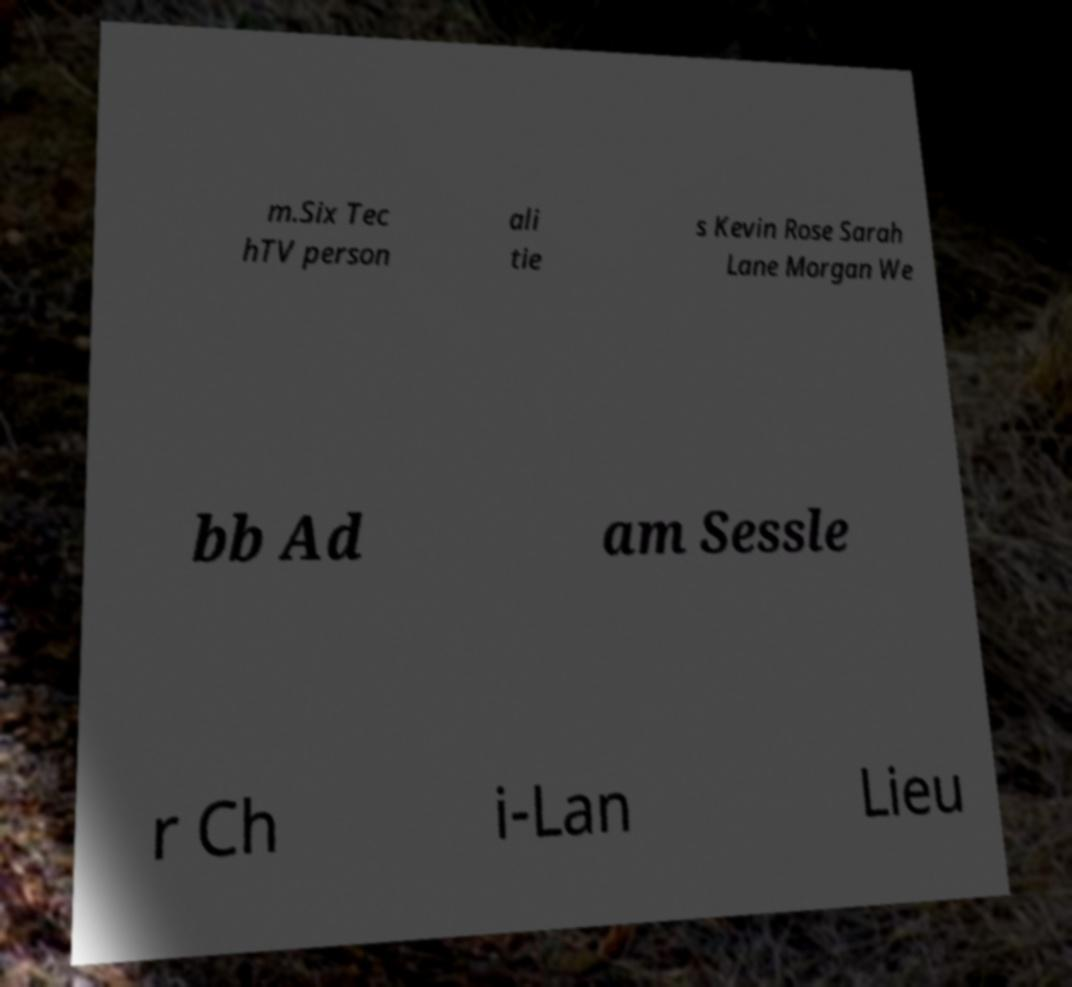What messages or text are displayed in this image? I need them in a readable, typed format. m.Six Tec hTV person ali tie s Kevin Rose Sarah Lane Morgan We bb Ad am Sessle r Ch i-Lan Lieu 